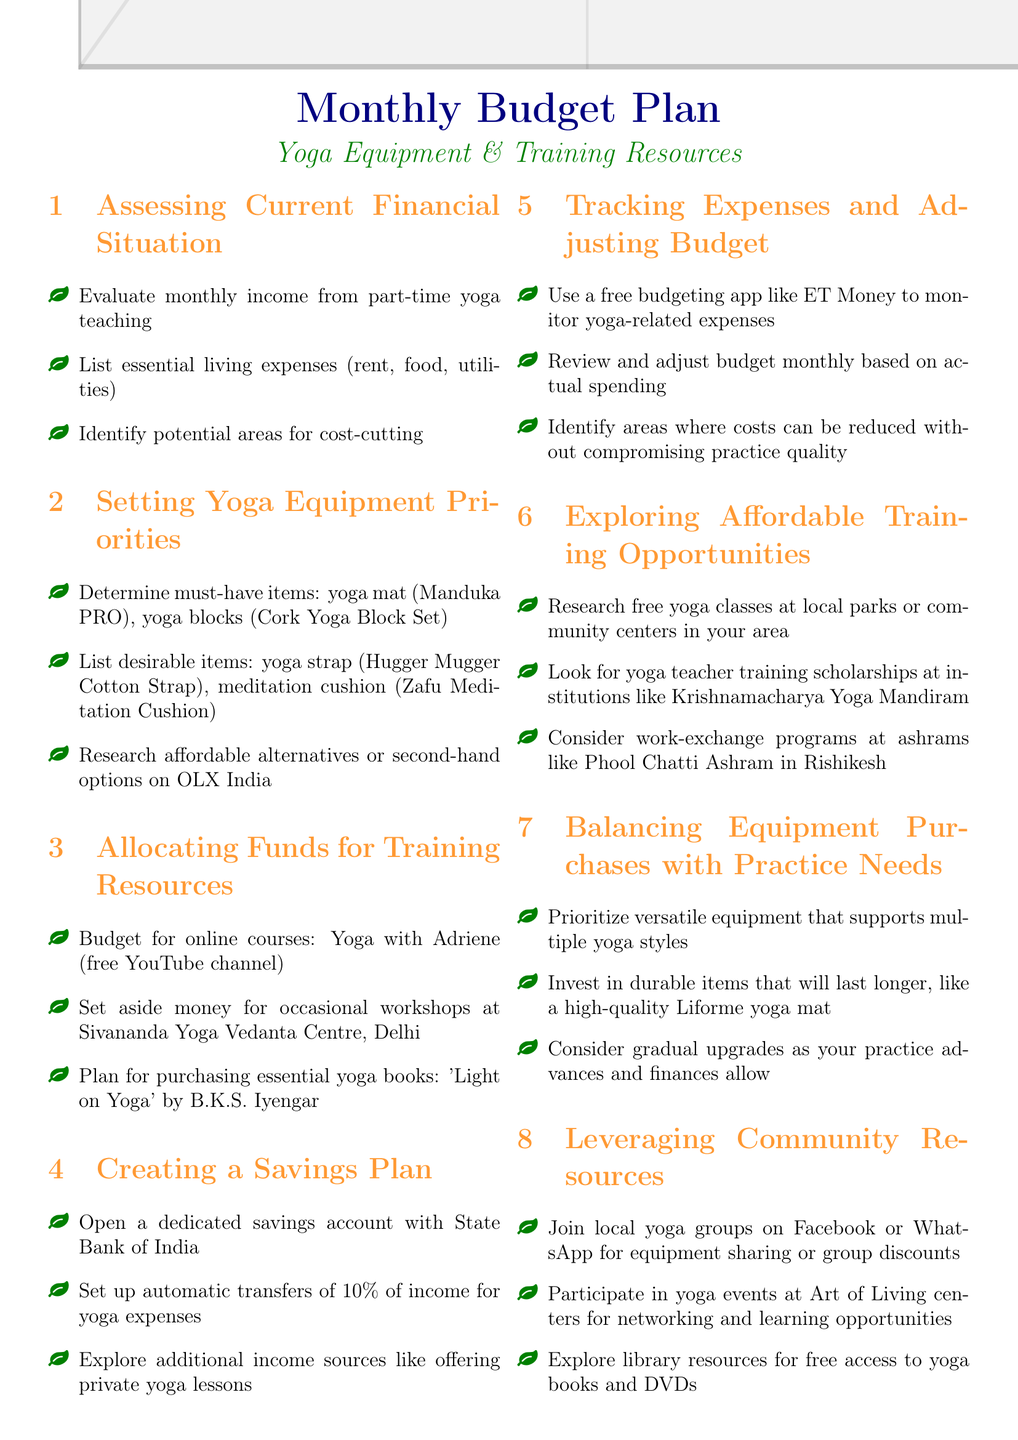What are the must-have yoga items? The must-have yoga items are specifically listed under the second agenda item, which includes a yoga mat and yoga blocks.
Answer: yoga mat (Manduka PRO), yoga blocks (Cork Yoga Block Set) What percentage of income is suggested for automatic transfers? The document mentions setting up automatic transfers of a specific percentage for yoga expenses.
Answer: 10% Where can someone find second-hand yoga equipment? The agenda suggests researching affordable alternatives or second-hand options at a specific website in India.
Answer: OLX India Which book is planned for purchase in the training resources section? The document specifically names the essential yoga book planned for purchase in the training resources section.
Answer: 'Light on Yoga' by B.K.S. Iyengar What type of budgeting app is recommended? The document provides a suggestion for a free app to help track yoga expenses.
Answer: ET Money What is one way to explore community resources? The document suggests a specific action to engage with local yoga groups for resources.
Answer: Join local yoga groups on Facebook or WhatsApp What financial institution is mentioned for opening a savings account? The agenda states a specific bank where a dedicated savings account should be opened.
Answer: State Bank of India What is one affordable training opportunity mentioned? The document highlights a specific way to access affordable yoga training opportunities in local parks.
Answer: Research free yoga classes at local parks or community centers 